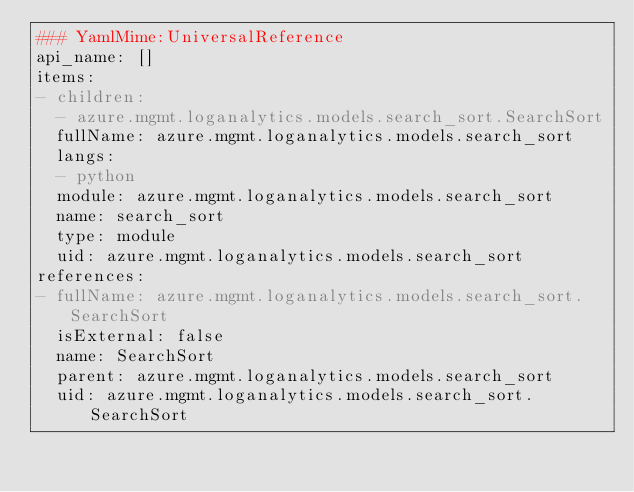<code> <loc_0><loc_0><loc_500><loc_500><_YAML_>### YamlMime:UniversalReference
api_name: []
items:
- children:
  - azure.mgmt.loganalytics.models.search_sort.SearchSort
  fullName: azure.mgmt.loganalytics.models.search_sort
  langs:
  - python
  module: azure.mgmt.loganalytics.models.search_sort
  name: search_sort
  type: module
  uid: azure.mgmt.loganalytics.models.search_sort
references:
- fullName: azure.mgmt.loganalytics.models.search_sort.SearchSort
  isExternal: false
  name: SearchSort
  parent: azure.mgmt.loganalytics.models.search_sort
  uid: azure.mgmt.loganalytics.models.search_sort.SearchSort
</code> 